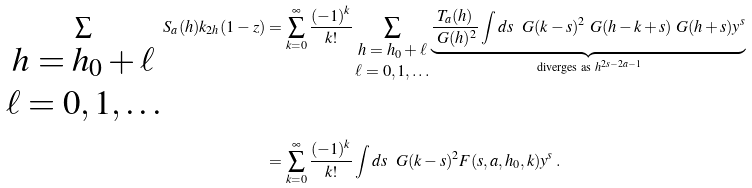<formula> <loc_0><loc_0><loc_500><loc_500>\sum _ { \begin{matrix} h = h _ { 0 } + \ell \\ \ell = 0 , 1 , \dots \end{matrix} } S _ { a } ( h ) k _ { 2 h } ( 1 - z ) & = \sum _ { k = 0 } ^ { \infty } \frac { ( - 1 ) ^ { k } } { k ! } \sum _ { \begin{matrix} h = h _ { 0 } + \ell \\ \ell = 0 , 1 , \dots \end{matrix} } \underbrace { \frac { T _ { a } ( h ) } { \ G ( h ) ^ { 2 } } \int d s \ \ G ( k - s ) ^ { 2 } \ G ( h - k + s ) \ G ( h + s ) y ^ { s } } _ { \text {diverges as} \ h ^ { 2 s - 2 a - 1 } } \\ & = \sum _ { k = 0 } ^ { \infty } \frac { ( - 1 ) ^ { k } } { k ! } \int d s \ \ G ( k - s ) ^ { 2 } F ( s , a , h _ { 0 } , k ) y ^ { s } \, .</formula> 